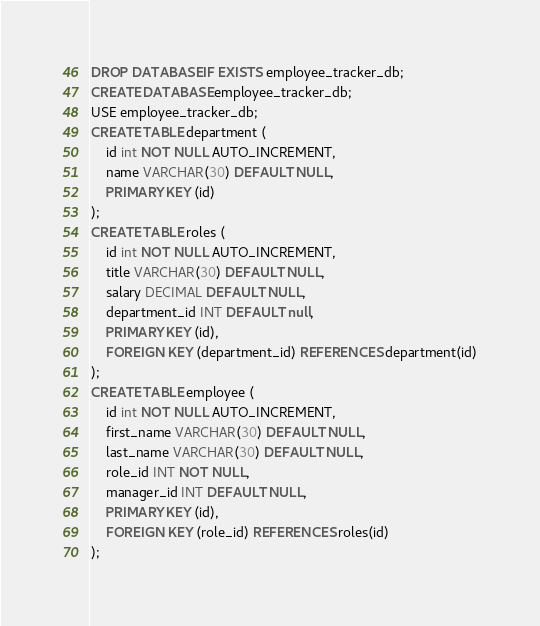Convert code to text. <code><loc_0><loc_0><loc_500><loc_500><_SQL_>DROP DATABASE IF EXISTS employee_tracker_db;
CREATE DATABASE employee_tracker_db;
USE employee_tracker_db;
CREATE TABLE department (
    id int NOT NULL AUTO_INCREMENT,
    name VARCHAR(30) DEFAULT NULL,
    PRIMARY KEY (id)
);
CREATE TABLE roles (
    id int NOT NULL AUTO_INCREMENT,
    title VARCHAR(30) DEFAULT NULL,
    salary DECIMAL DEFAULT NULL,
    department_id INT DEFAULT null,
    PRIMARY KEY (id),
    FOREIGN KEY (department_id) REFERENCES department(id)
);
CREATE TABLE employee (
    id int NOT NULL AUTO_INCREMENT,
    first_name VARCHAR(30) DEFAULT NULL,
    last_name VARCHAR(30) DEFAULT NULL,
    role_id INT NOT NULL,
    manager_id INT DEFAULT NULL,
    PRIMARY KEY (id),
    FOREIGN KEY (role_id) REFERENCES roles(id)
);</code> 